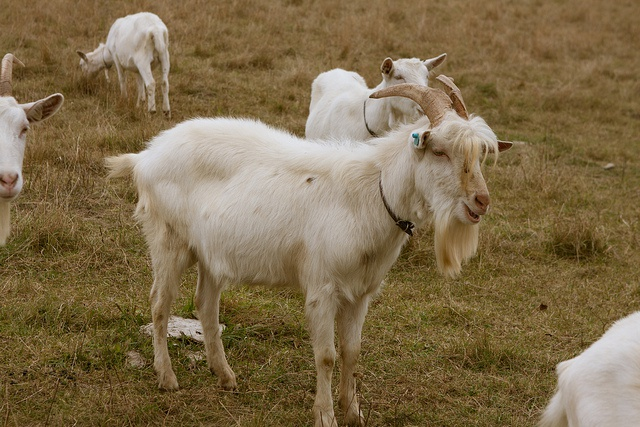Describe the objects in this image and their specific colors. I can see sheep in olive, darkgray, and gray tones, sheep in olive, darkgray, and lightgray tones, sheep in olive, lightgray, darkgray, and gray tones, sheep in olive, darkgray, lightgray, and gray tones, and sheep in olive, darkgray, gray, lightgray, and maroon tones in this image. 